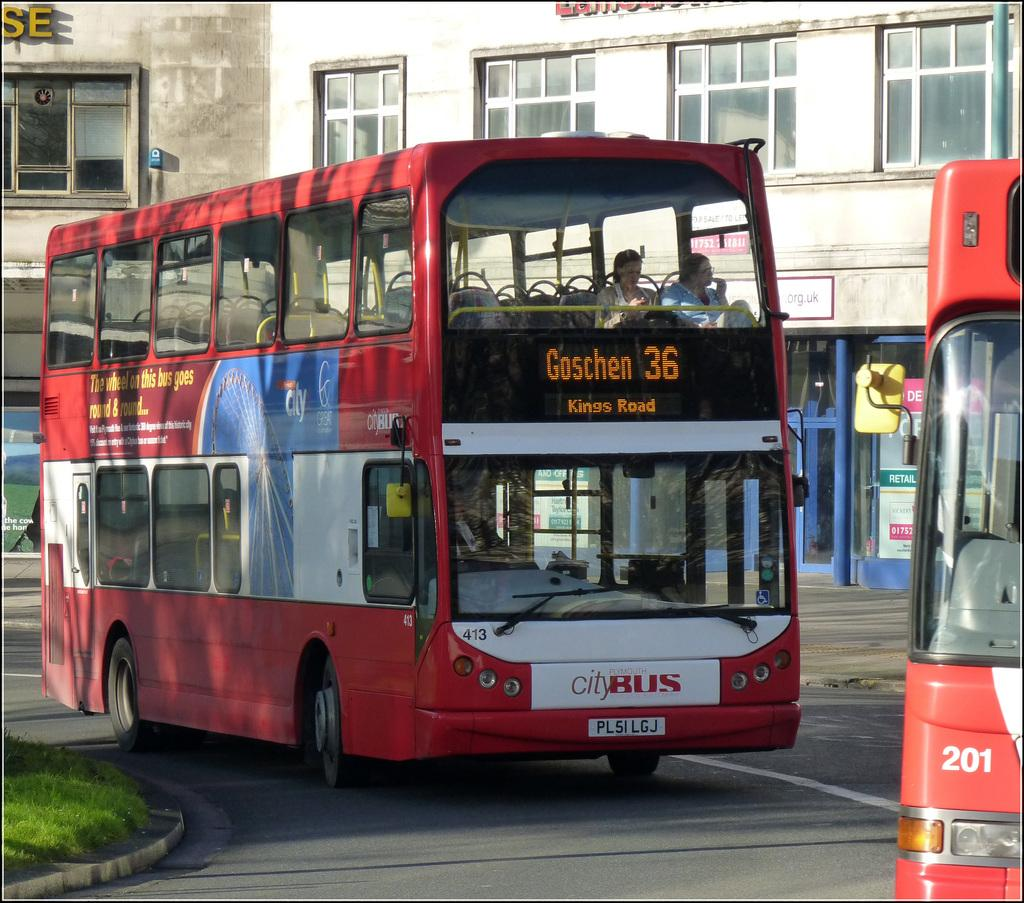<image>
Create a compact narrative representing the image presented. Red double decker bus heading to Kings Road 